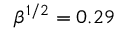Convert formula to latex. <formula><loc_0><loc_0><loc_500><loc_500>\beta ^ { 1 / 2 } = 0 . 2 9</formula> 